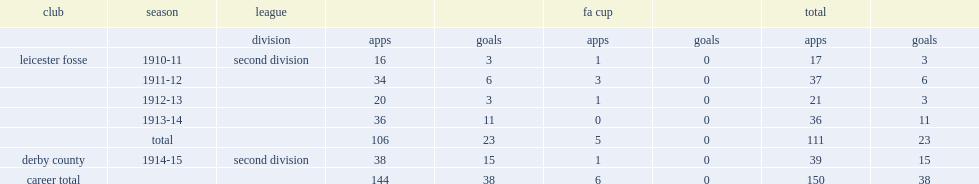Over the following four seasons, how many appearances did tommy benfield make with 23 goals in total? 111.0. 